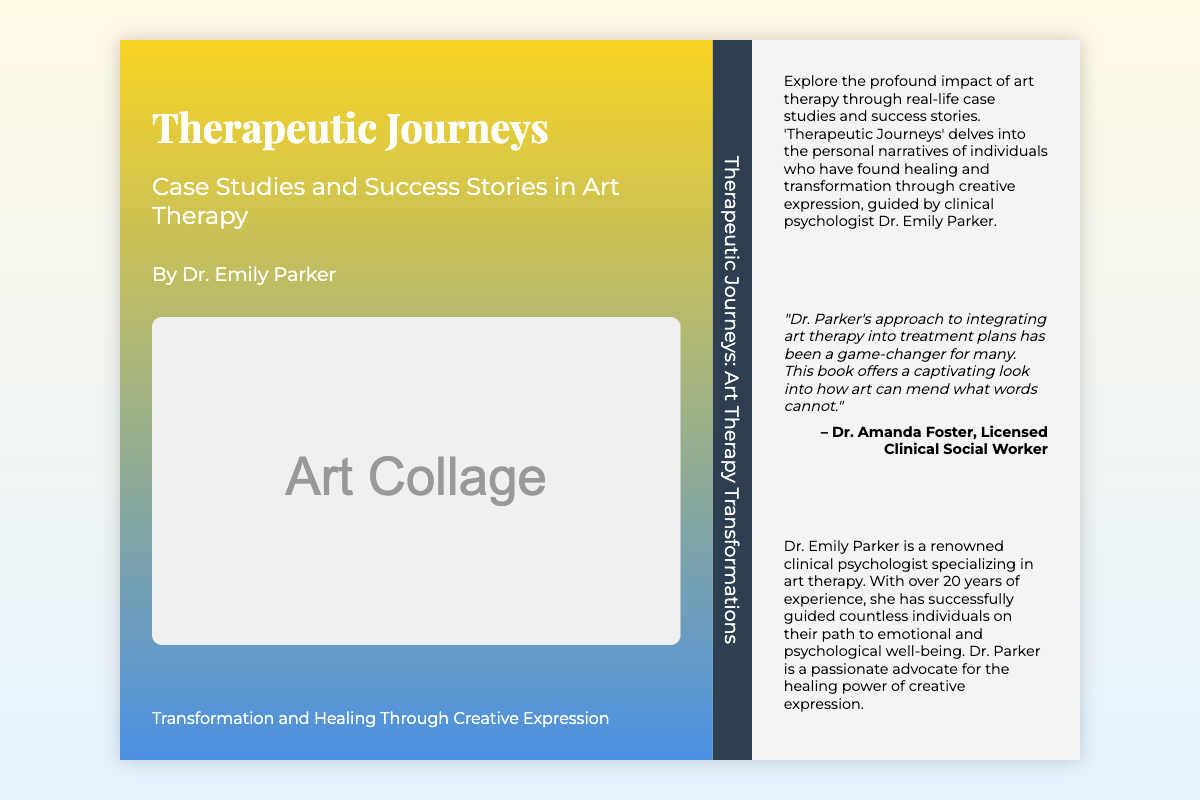What is the title of the book? The title of the book is prominently displayed on the front cover.
Answer: Therapeutic Journeys Who is the author of the book? The author's name is mentioned in the front cover section.
Answer: Dr. Emily Parker What type of therapy is the book focused on? The book cover indicates the therapeutic focus through the subtitle.
Answer: Art Therapy What does the collage represent on the front cover? The collage signifies transformation and healing, as mentioned in the front cover text.
Answer: Transformation and Healing Who provided a testimonial for the book? The testimonial section indicates the person providing feedback on the author's work.
Answer: Dr. Amanda Foster How many years of experience does Dr. Emily Parker have? The author bio section provides a specific mention of the years of experience.
Answer: 20 years What is the main purpose of the book according to the summary? The summary describes the intent of the book regarding individual experiences.
Answer: Healing and transformation What color scheme is used for the front cover? The front cover design features a specific gradient color scheme.
Answer: Blue and yellow gradient What is emphasized as a key aspect of the book's content? The back cover summary mentions a specific aspect of the content.
Answer: Real-life case studies 